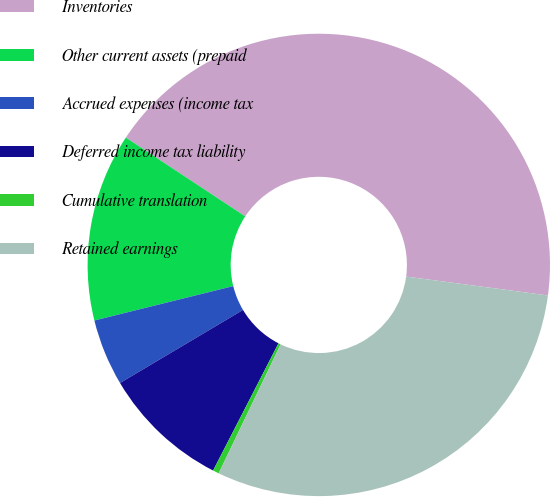<chart> <loc_0><loc_0><loc_500><loc_500><pie_chart><fcel>Inventories<fcel>Other current assets (prepaid<fcel>Accrued expenses (income tax<fcel>Deferred income tax liability<fcel>Cumulative translation<fcel>Retained earnings<nl><fcel>42.82%<fcel>13.15%<fcel>4.67%<fcel>8.91%<fcel>0.43%<fcel>30.02%<nl></chart> 